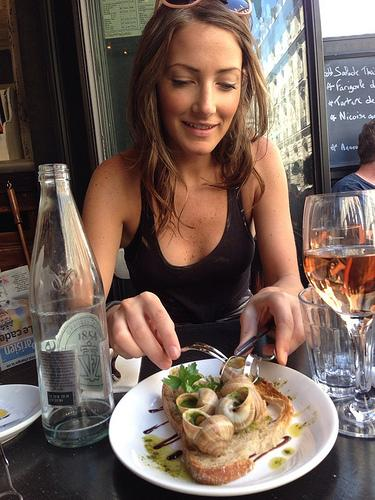Can you spot a piece of bread in the image? If yes, describe it. Yes, a piece of crusty bread with escargot and tan and brown shells is placed on a white plate. Examine the board in the image and describe what it displays. A chalkboard with white chalk writing displays menu specials on a white and black background. Summarize the scene on the table in the image. A woman is having lunch, which consists of escargot on toast, a glass of wine, and an empty glass bottle on a black wooden table. Count the number of bottles in the image and describe their characteristics. There are two bottles: an empty glass bottle with a silver label marked "1854" and a tall clear bottle with a silver and black label. Analyze the sentiment or mood of the image based on the objects and details. The image displays a relaxed and enjoyable lunch scene, with a woman indulging in a delicious meal of escargot, toast, and wine. How many glasses are present in the image, and what do they contain? There are three glasses: one large glass of wine filled with amber liquid, one short empty glass, and an empty glass bottle with a label. Explain what utensils the woman is using and her reason for using them. The woman is using snail tongs and a snail fork to eat escargot, which require specific utensils for handling. Describe the presentation of the escargot dish. Escargot is served atop toasted bread, garnished with sauces on a round white ceramic plate. Provide a description of the woman's clothing and appearance. The woman is wearing a black tank top, has several freckles on her chest, and has sunglasses propped on top of her head. Identify the person in the image and the activity they are engaged in. A woman with long brown hair and sunglasses is eating escargot while holding silver utensils in her hands. Name the food items found on the white plate. Escargot, toast, and chocolate sauce What is the woman doing in the image? Eating escargot What is written on the label of the empty glass bottle? 1854 Determine any unique features or attributes of the woman's physical appearance. Light-skinned with freckles on her chest Which object is on the top of the woman's head? Sunglasses What type of shirt is the woman wearing? Black tank top What type of utensils is the woman using? Snail tongs and snail fork Describe the hairstyle of the woman. Long brown hair Describe the contents of the round white ceramic plate. Escargot on toast and chocolate sauce What is the color of the wine inside the wine glass? Peach Choose the correct statement about the woman's clothing. a) She is wearing a white shirt. b) She is wearing a red dress. c) She is wearing a black tank top. c) She is wearing a black tank top. List the objects on the table. Escargot, bread, wine glass, empty glass bottle, white plate, utensils, and chocolate sauce Identify the text on the chalkboard. Menu specials Identify the type of food on the toast. Escargot What is the color of the beverage in the wine glass? Amber Create a story that includes a woman, escargot, and a chalkboard. A hungry woman went to a fancy French restaurant, where the menu specials were written on a chalkboard. Intrigued, she ordered the escargot and enjoyed a delicious meal. Describe the object the woman is holding in her hands. Utensils for eating snails What is the special feature on the label of the empty glass bottle? Silver and black label with 1854 written on it Mention any facial features of the woman that are visible. Freckles on her chest 